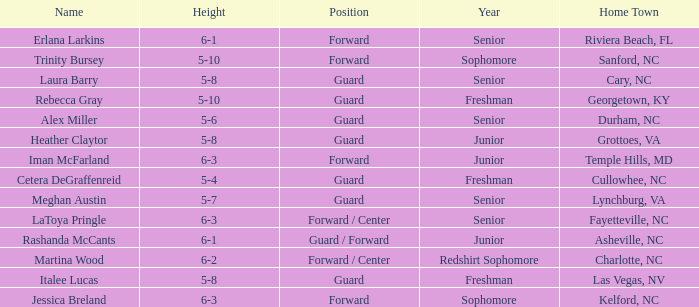How tall is the freshman guard Cetera Degraffenreid? 5-4. 